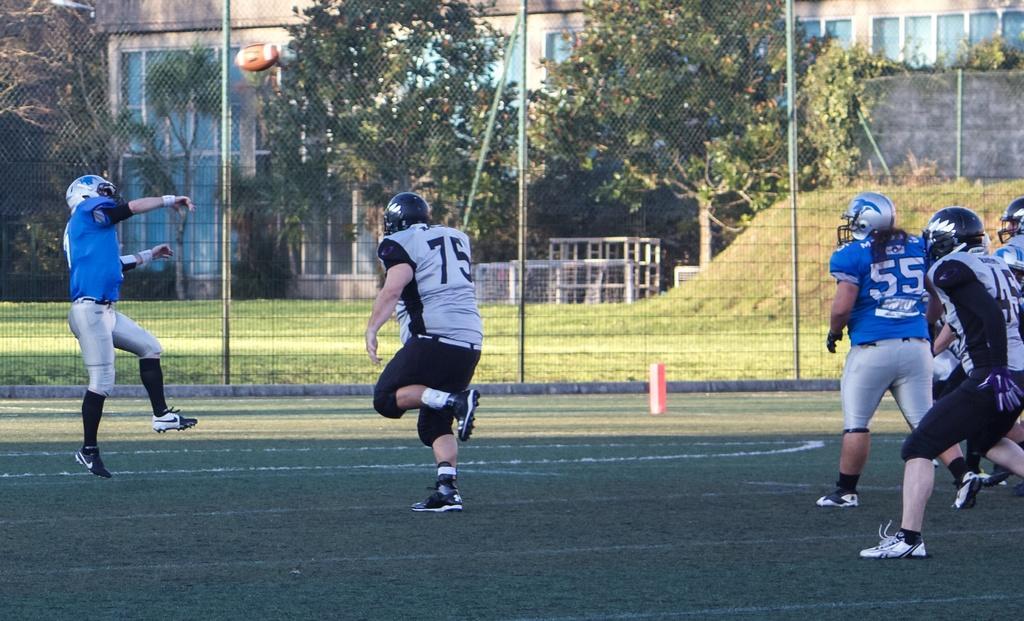Please provide a concise description of this image. In this picture we can see some people are playing spring football game, they wore helmets and shoes, we can see fencing in the middle, in the background there are some trees, grass and a building. 